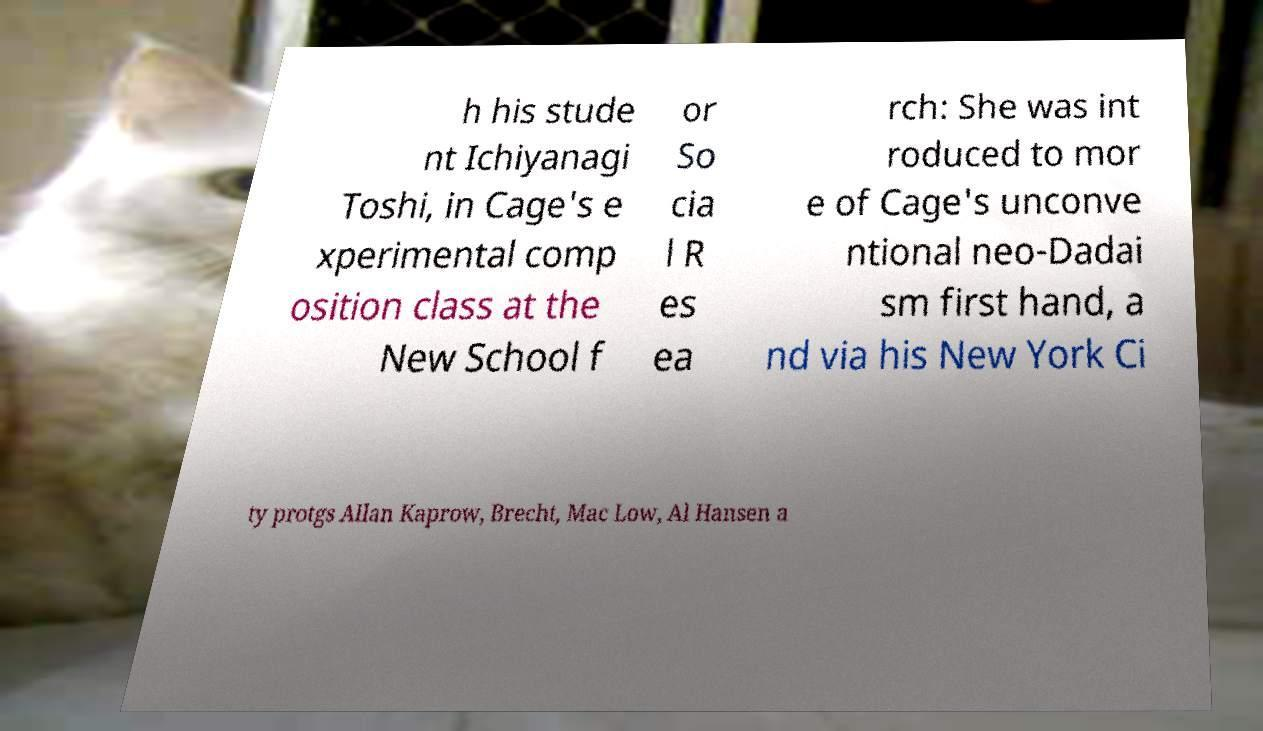There's text embedded in this image that I need extracted. Can you transcribe it verbatim? h his stude nt Ichiyanagi Toshi, in Cage's e xperimental comp osition class at the New School f or So cia l R es ea rch: She was int roduced to mor e of Cage's unconve ntional neo-Dadai sm first hand, a nd via his New York Ci ty protgs Allan Kaprow, Brecht, Mac Low, Al Hansen a 